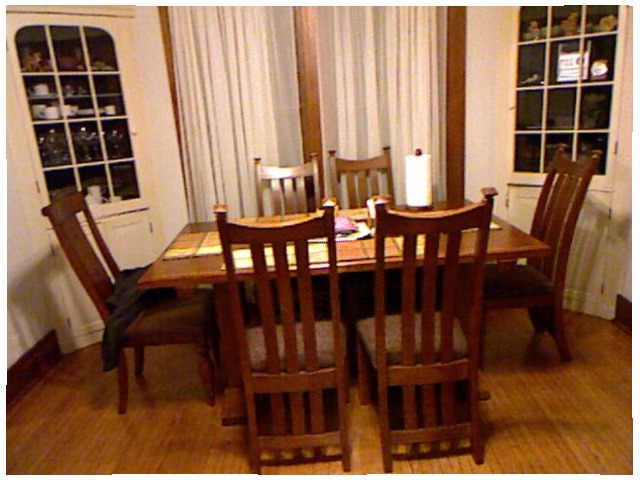<image>
Is the chair in front of the curtain? Yes. The chair is positioned in front of the curtain, appearing closer to the camera viewpoint. Is the chairs under the table? Yes. The chairs is positioned underneath the table, with the table above it in the vertical space. Is the cup in the cabinet? Yes. The cup is contained within or inside the cabinet, showing a containment relationship. Is there a chair behind the chair? No. The chair is not behind the chair. From this viewpoint, the chair appears to be positioned elsewhere in the scene. 